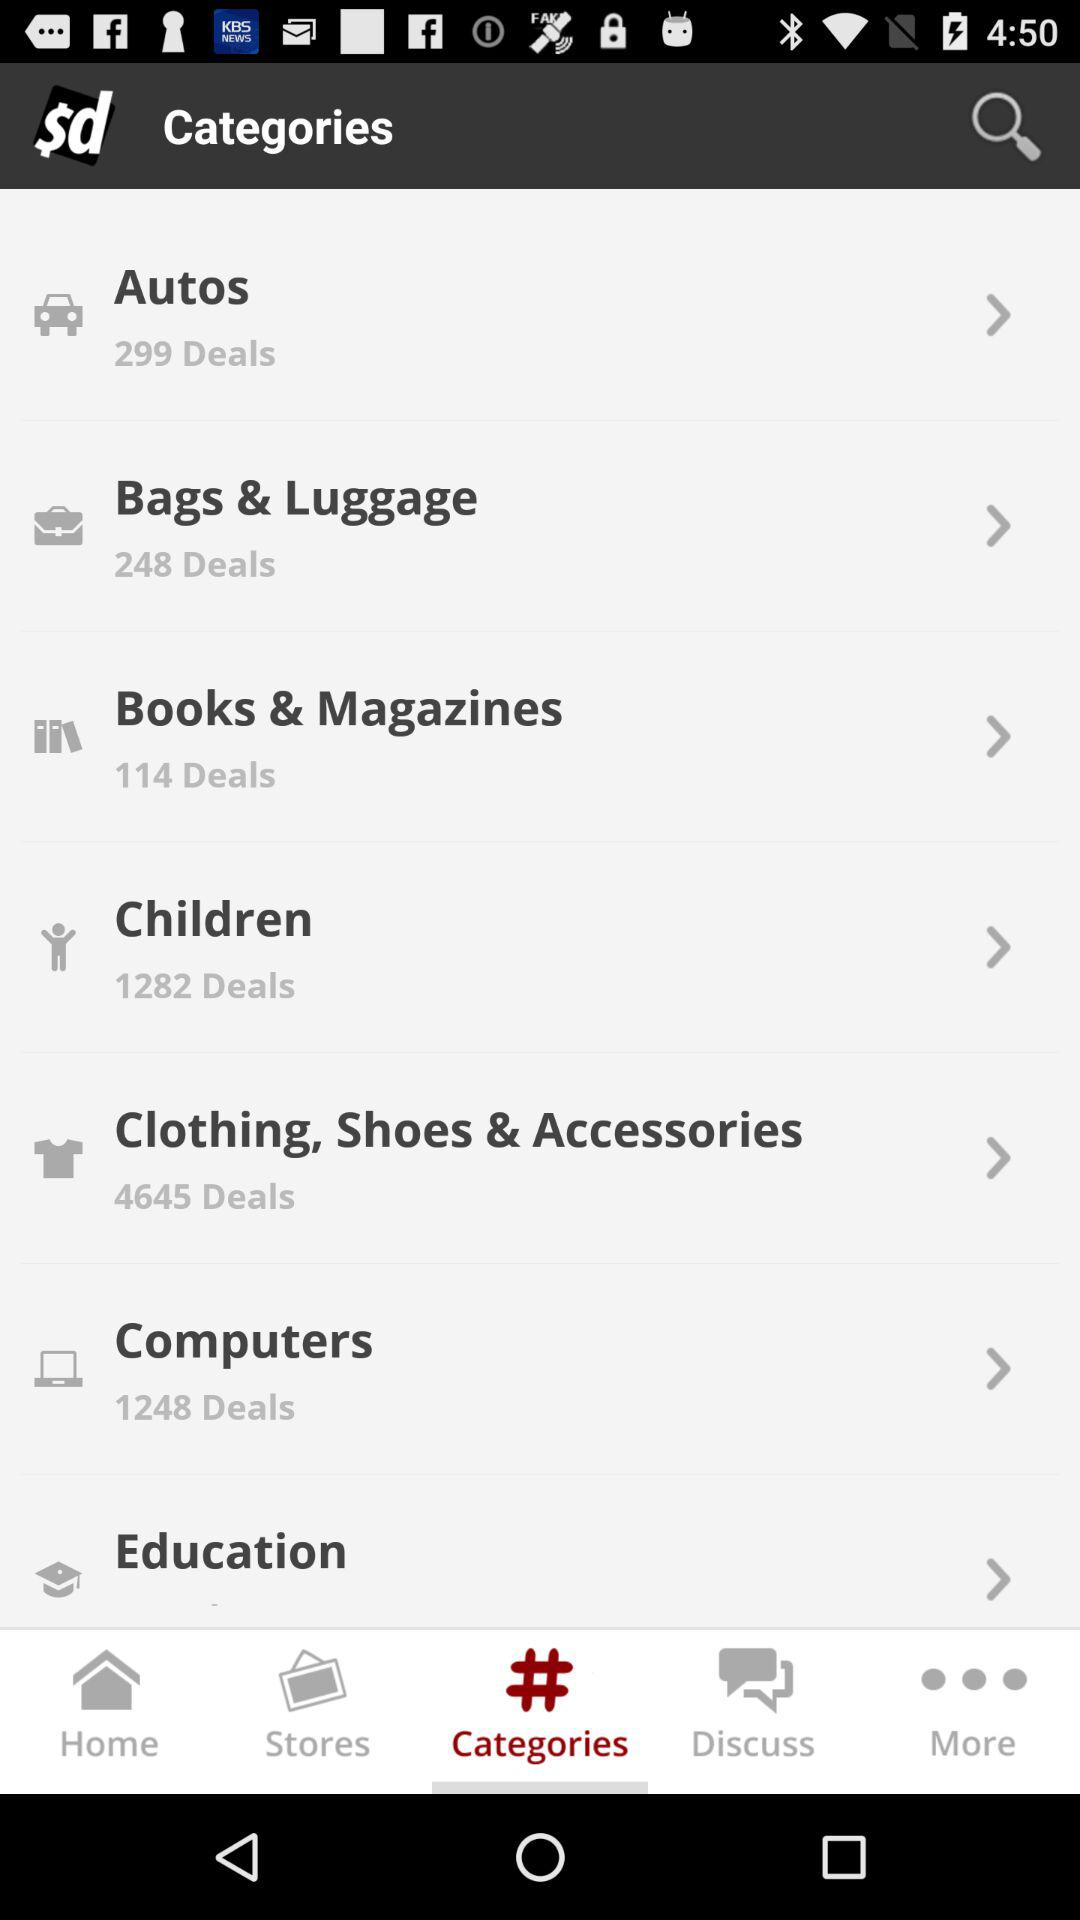How many deals are in "Autos"? There are 299 deals in "Autos". 